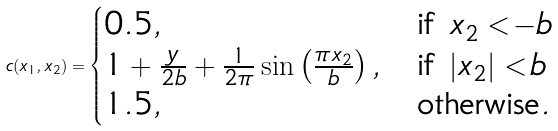<formula> <loc_0><loc_0><loc_500><loc_500>c ( x _ { 1 } , x _ { 2 } ) = \begin{cases} 0 . 5 , & \text {if $ x_{2}< - b $} \\ 1 + \frac { y } { 2 b } + \frac { 1 } { 2 \pi } \sin \left ( \frac { \pi x _ { 2 } } { b } \right ) , & \text {if $|x_{2}|<b $} \\ 1 . 5 , & \text {otherwise} . \end{cases}</formula> 